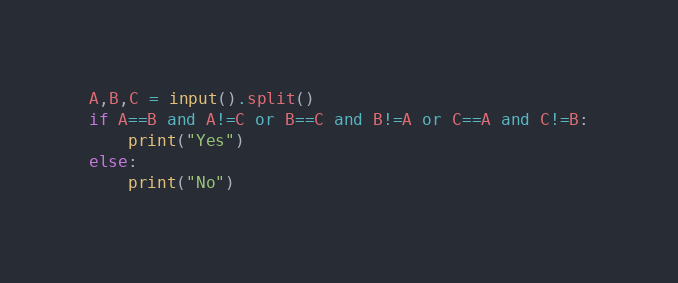<code> <loc_0><loc_0><loc_500><loc_500><_Python_>A,B,C = input().split()
if A==B and A!=C or B==C and B!=A or C==A and C!=B:
    print("Yes")
else:
    print("No")</code> 